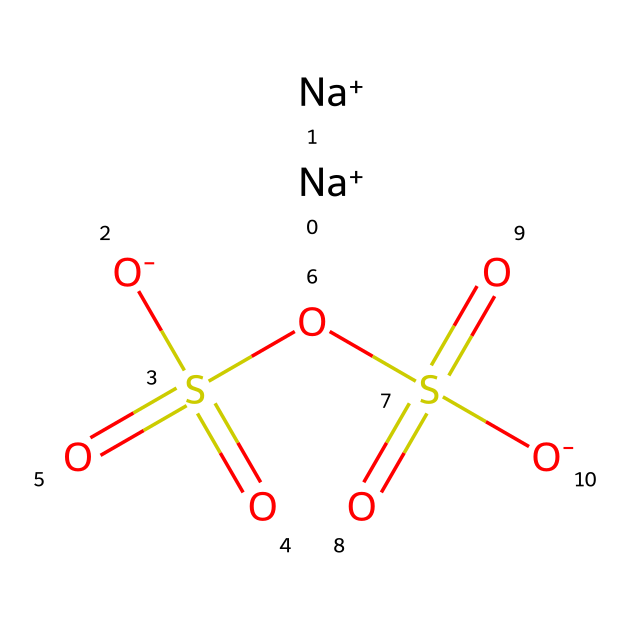how many sodium atoms are present in sodium metabisulfite? The structure shows two sodium ions represented by [Na+], indicating that there are two sodium atoms in total in sodium metabisulfite.
Answer: two what is the oxidation state of sulfur in sodium metabisulfite? In the chemical structure, the sulfur atom is part of two sulfate groups (OS(=O)(=O)), and considering the overall charge of the compound being neutral, the oxidation state of sulfur is +4.
Answer: four what type of chemical is sodium metabisulfite classified as? Sodium metabisulfite is classified as a preservative and antioxidant, belonging to the category of sulfur compounds due to the presence of sulfur atoms.
Answer: preservative how many oxygen atoms are present in sodium metabisulfite? By examining the structure, there are a total of six oxygen atoms indicated by [O-] and the two sulfate groups (OS(=O)(=O)), which each contribute three oxygen atoms.
Answer: six what functional groups are present in sodium metabisulfite? The presence of the sulfite group (SO3) along with the sodium cations indicates that the main functional group in sodium metabisulfite is a sulfite.
Answer: sulfite why is sodium metabisulfite used as a preservative? Sodium metabisulfite works as a preservative due to its ability to release sulfur dioxide (SO2) when dissolved, which inhibits the growth of microbes and preserves food quality.
Answer: inhibits microbes 